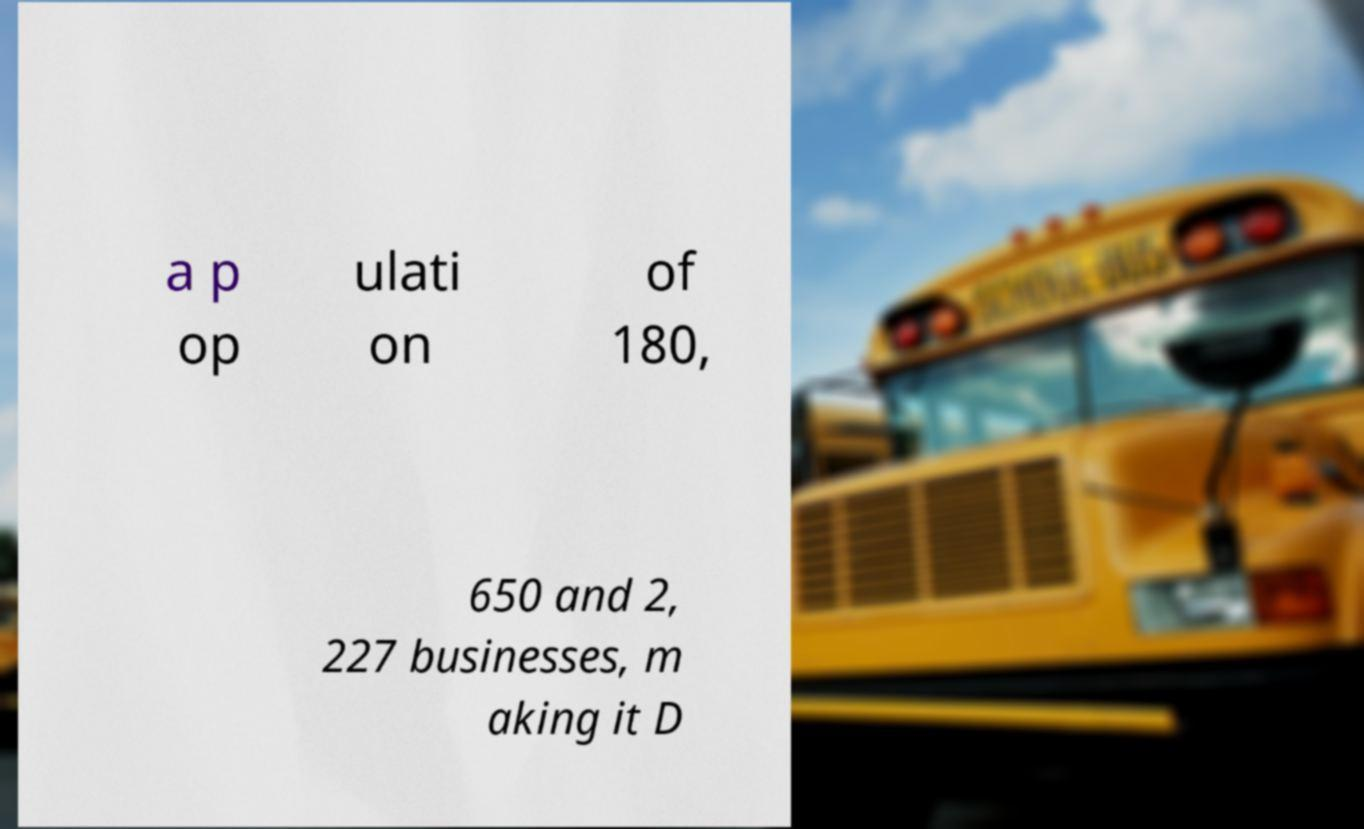Can you accurately transcribe the text from the provided image for me? a p op ulati on of 180, 650 and 2, 227 businesses, m aking it D 